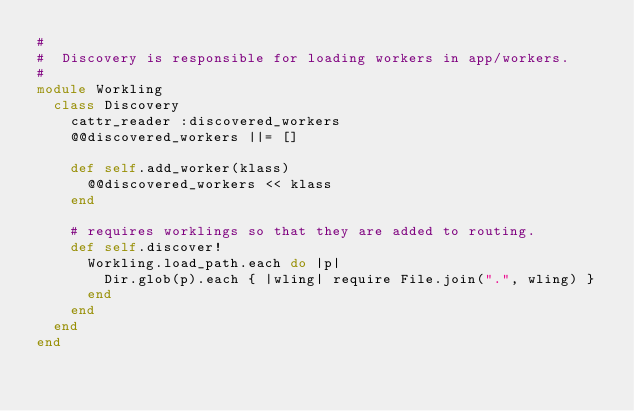<code> <loc_0><loc_0><loc_500><loc_500><_Ruby_>#
#  Discovery is responsible for loading workers in app/workers.
#
module Workling
  class Discovery
    cattr_reader :discovered_workers
    @@discovered_workers ||= []

    def self.add_worker(klass)
      @@discovered_workers << klass
    end

    # requires worklings so that they are added to routing.
    def self.discover!
      Workling.load_path.each do |p|
        Dir.glob(p).each { |wling| require File.join(".", wling) }
      end
    end
  end
end
</code> 